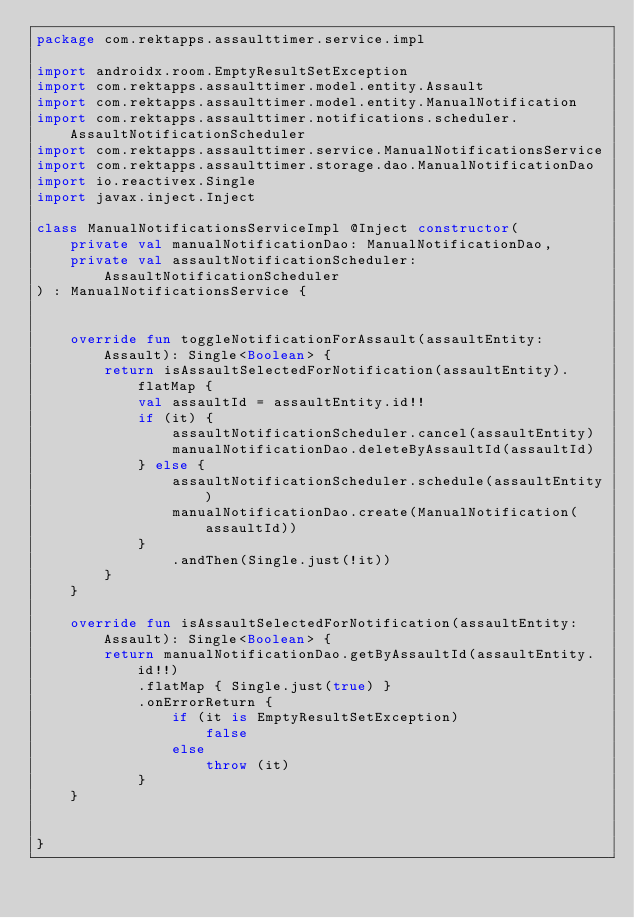Convert code to text. <code><loc_0><loc_0><loc_500><loc_500><_Kotlin_>package com.rektapps.assaulttimer.service.impl

import androidx.room.EmptyResultSetException
import com.rektapps.assaulttimer.model.entity.Assault
import com.rektapps.assaulttimer.model.entity.ManualNotification
import com.rektapps.assaulttimer.notifications.scheduler.AssaultNotificationScheduler
import com.rektapps.assaulttimer.service.ManualNotificationsService
import com.rektapps.assaulttimer.storage.dao.ManualNotificationDao
import io.reactivex.Single
import javax.inject.Inject

class ManualNotificationsServiceImpl @Inject constructor(
    private val manualNotificationDao: ManualNotificationDao,
    private val assaultNotificationScheduler: AssaultNotificationScheduler
) : ManualNotificationsService {


    override fun toggleNotificationForAssault(assaultEntity: Assault): Single<Boolean> {
        return isAssaultSelectedForNotification(assaultEntity).flatMap {
            val assaultId = assaultEntity.id!!
            if (it) {
                assaultNotificationScheduler.cancel(assaultEntity)
                manualNotificationDao.deleteByAssaultId(assaultId)
            } else {
                assaultNotificationScheduler.schedule(assaultEntity)
                manualNotificationDao.create(ManualNotification(assaultId))
            }
                .andThen(Single.just(!it))
        }
    }

    override fun isAssaultSelectedForNotification(assaultEntity: Assault): Single<Boolean> {
        return manualNotificationDao.getByAssaultId(assaultEntity.id!!)
            .flatMap { Single.just(true) }
            .onErrorReturn {
                if (it is EmptyResultSetException)
                    false
                else
                    throw (it)
            }
    }


}


</code> 